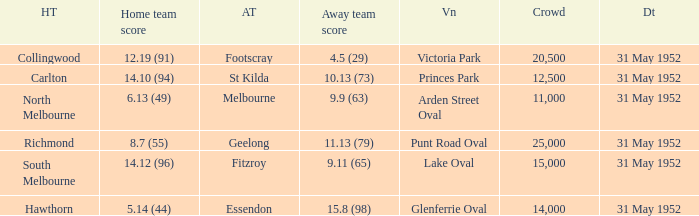When was the game when Footscray was the away team? 31 May 1952. 